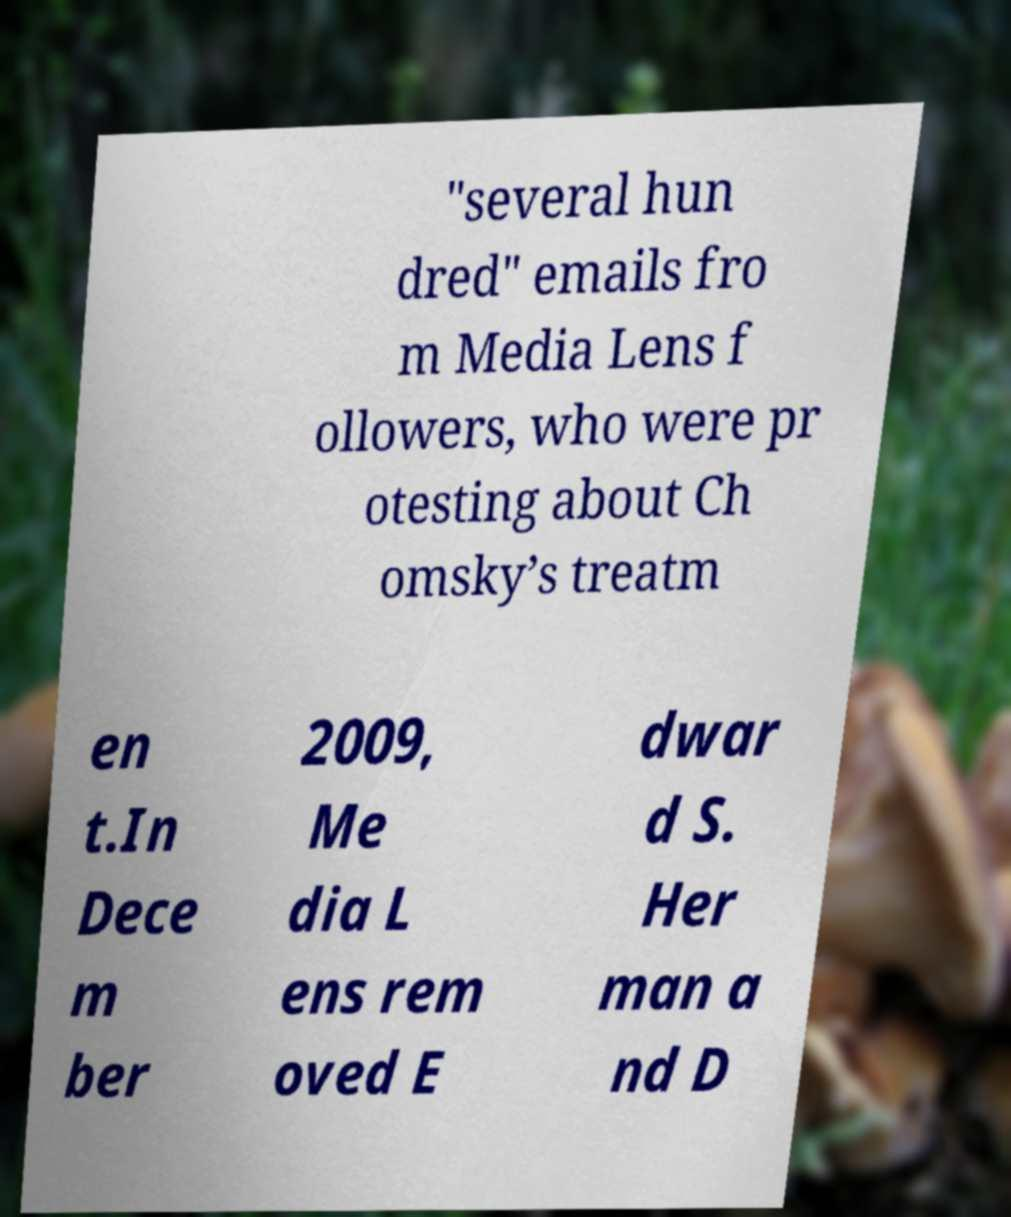Can you accurately transcribe the text from the provided image for me? "several hun dred" emails fro m Media Lens f ollowers, who were pr otesting about Ch omsky’s treatm en t.In Dece m ber 2009, Me dia L ens rem oved E dwar d S. Her man a nd D 